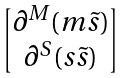<formula> <loc_0><loc_0><loc_500><loc_500>\begin{bmatrix} \partial ^ { M } ( m \tilde { s } ) \\ \partial ^ { S } ( s \tilde { s } ) \end{bmatrix}</formula> 